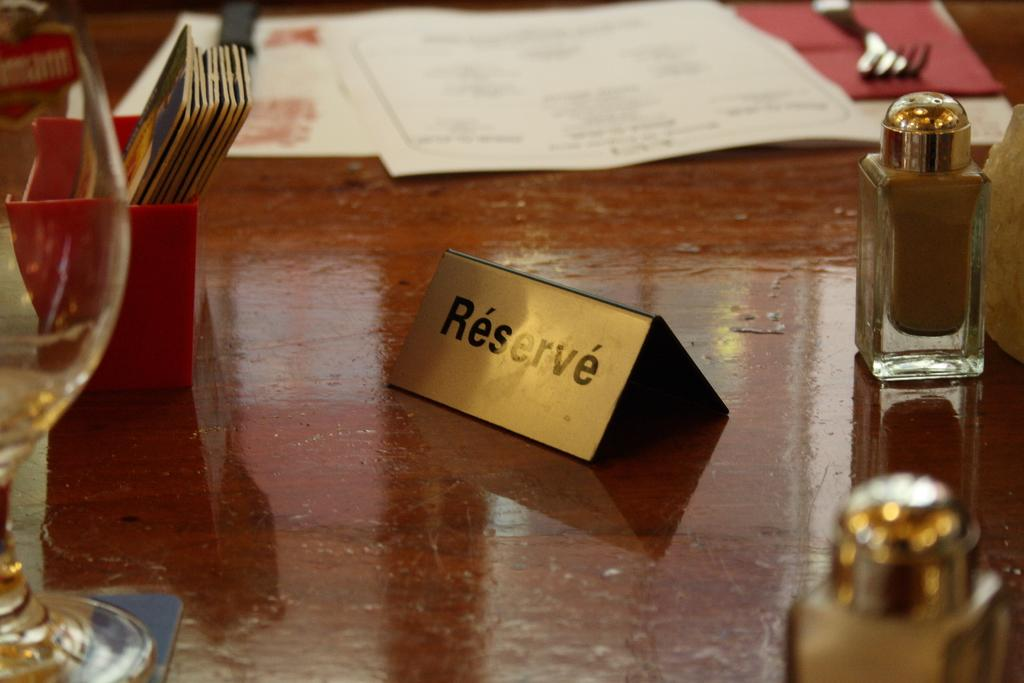<image>
Share a concise interpretation of the image provided. A table with salt and pepper shakers and a gold colored Reserve sign. 